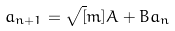Convert formula to latex. <formula><loc_0><loc_0><loc_500><loc_500>a _ { n + 1 } = \sqrt { [ } m ] { A + B a _ { n } }</formula> 